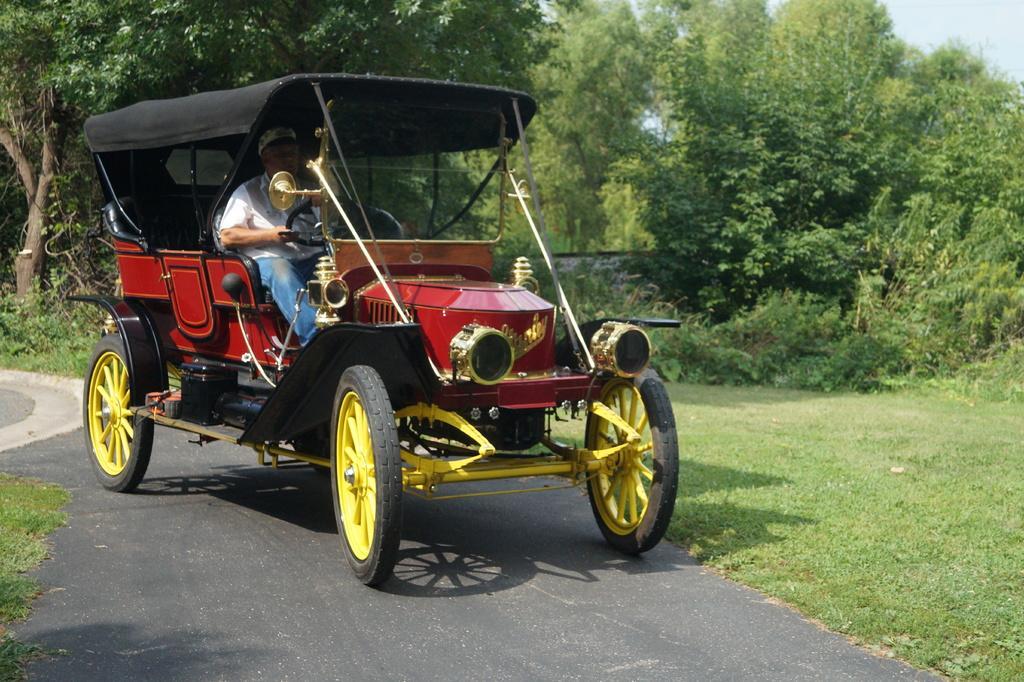Can you describe this image briefly? In this image we can see a man sitting in the cart, trees, ground, bushes and sky. 